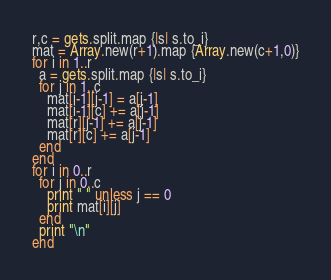Convert code to text. <code><loc_0><loc_0><loc_500><loc_500><_Ruby_>r,c = gets.split.map {|s| s.to_i}
mat = Array.new(r+1).map {Array.new(c+1,0)}
for i in 1..r
  a = gets.split.map {|s| s.to_i}
  for j in 1..c
    mat[i-1][j-1] = a[j-1]
    mat[i-1][c] += a[j-1]
    mat[r][j-1] += a[j-1]
    mat[r][c] += a[j-1]
  end
end
for i in 0..r
  for j in 0..c
    print " " unless j == 0
    print mat[i][j]
  end
  print "\n"
end</code> 